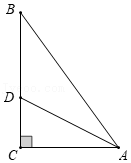Suppose we have a diagram representing right triangle ABC, with angle C measuring 90 degrees. The bisector of angle BAC, denoted as AD, intersects side BC at point D. If triangle ACD has an area of 6 square units and the length of side AC is 6 units, what is the length of the segment from point D to AB? In the right triangle ABC, angle C is a right angle, and AD is the bisector of angle BAC, intersecting side BC at D. Given that triangle ACD has an area of 6 square units and side AC measures 6 units, we can determine the length of segment CD. Since triangle ACD is a right triangle (as AD is the angle bisector, making AC perpendicular to CD), the area can be expressed as 1/2 * base * height = 1/2 * AC * CD = 6. Solving for CD gives CD = 2 units. Since AD is the angle bisector and triangles ABC and ACD share similar properties, CD extends perpendicularly to meet AB at point E, making DE also equal to 2 units. Therefore, the length from D to AB is exactly 2 units. 